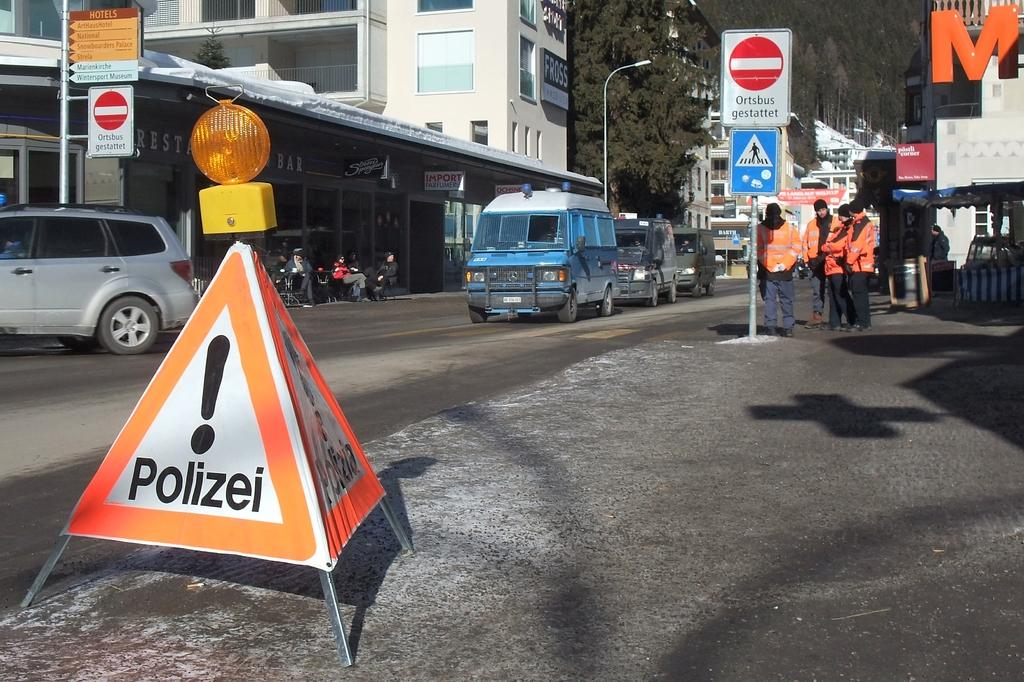<image>
Offer a succinct explanation of the picture presented. A triangle white and orange warning pylon for the Polizei. 